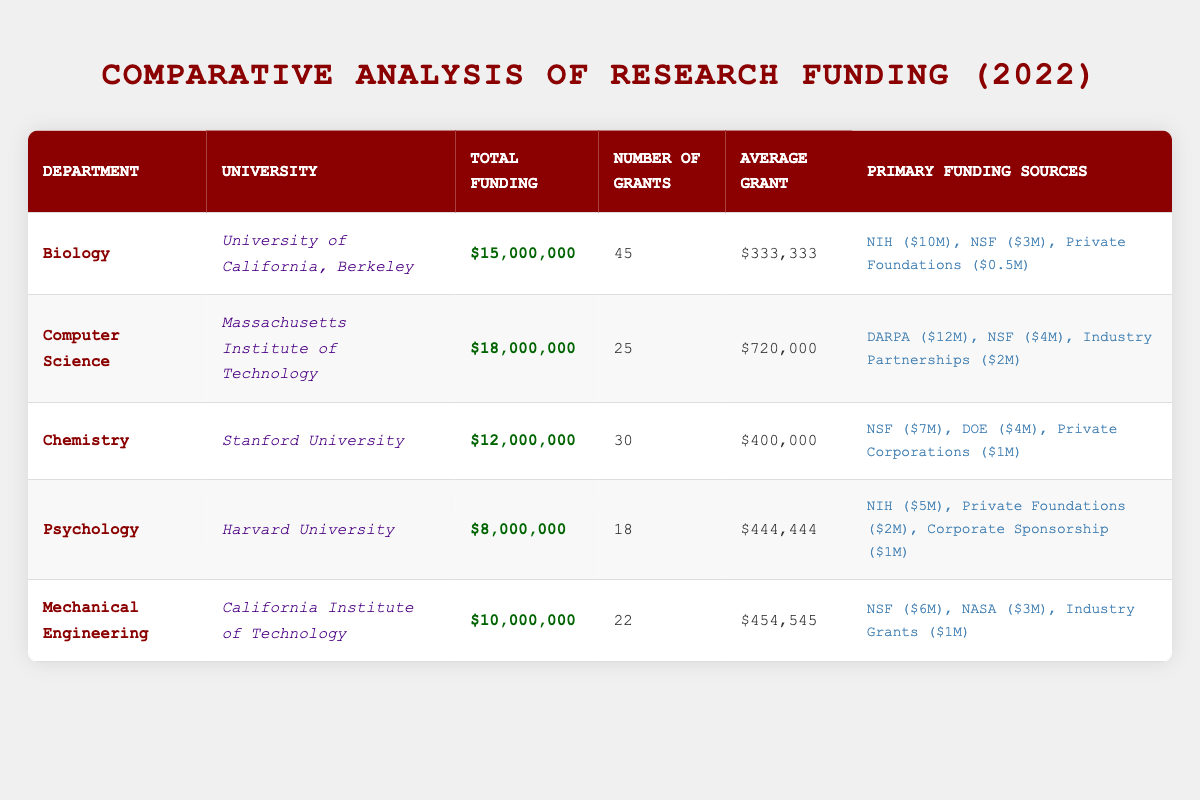What was the total funding received by the Computer Science department? The total funding for the Computer Science department, as indicated in the table, is $18,000,000.
Answer: $18,000,000 How many grants were received by the Psychology department? The table shows that the Psychology department received a total of 18 grants.
Answer: 18 What is the average grant amount for the Biology department? The average grant amount for the Biology department is listed in the table as $333,333.
Answer: $333,333 Which department received funding from the National Institutes of Health (NIH)? The Biology and Psychology departments received funding from the NIH, with Biology receiving $10,000,000 and Psychology receiving $5,000,000.
Answer: Biology and Psychology What is the total funding received by all departments combined? To find the total funding, sum the individual total funding amounts: $15,000,000 (Biology) + $18,000,000 (Computer Science) + $12,000,000 (Chemistry) + $8,000,000 (Psychology) + $10,000,000 (Mechanical Engineering) = $63,000,000.
Answer: $63,000,000 Did the Chemistry department receive more funding than the Mechanical Engineering department? The Chemistry department received $12,000,000, while the Mechanical Engineering department received $10,000,000, indicating that Chemistry received more funding.
Answer: Yes What is the total amount funded by the National Science Foundation (NSF) across all departments? The NSF funding amounts for each department are: Biology ($3,000,000), Computer Science ($4,000,000), Chemistry ($7,000,000), Mechanical Engineering ($6,000,000). Summing these yields $3,000,000 + $4,000,000 + $7,000,000 + $6,000,000 = $20,000,000.
Answer: $20,000,000 Which department has the highest average grant amount and what is it? The Computer Science department has the highest average grant amount of $720,000, as reflected in the table.
Answer: Computer Science, $720,000 Is it true that the total funding for the Psychology department is less than that of the Mechanical Engineering department? The total funding for Psychology is $8,000,000, while Mechanical Engineering received $10,000,000, which means the statement is true.
Answer: Yes 